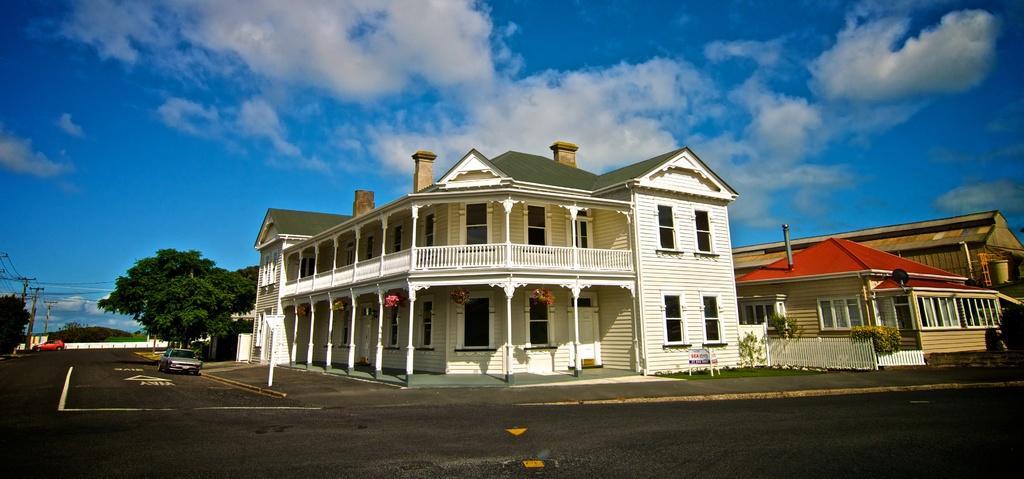How would you summarize this image in a sentence or two? In this image I can see few buildings,glass windows,plants,vehicles,current poles,wires,door and trees. The sky is in blue and white color. 